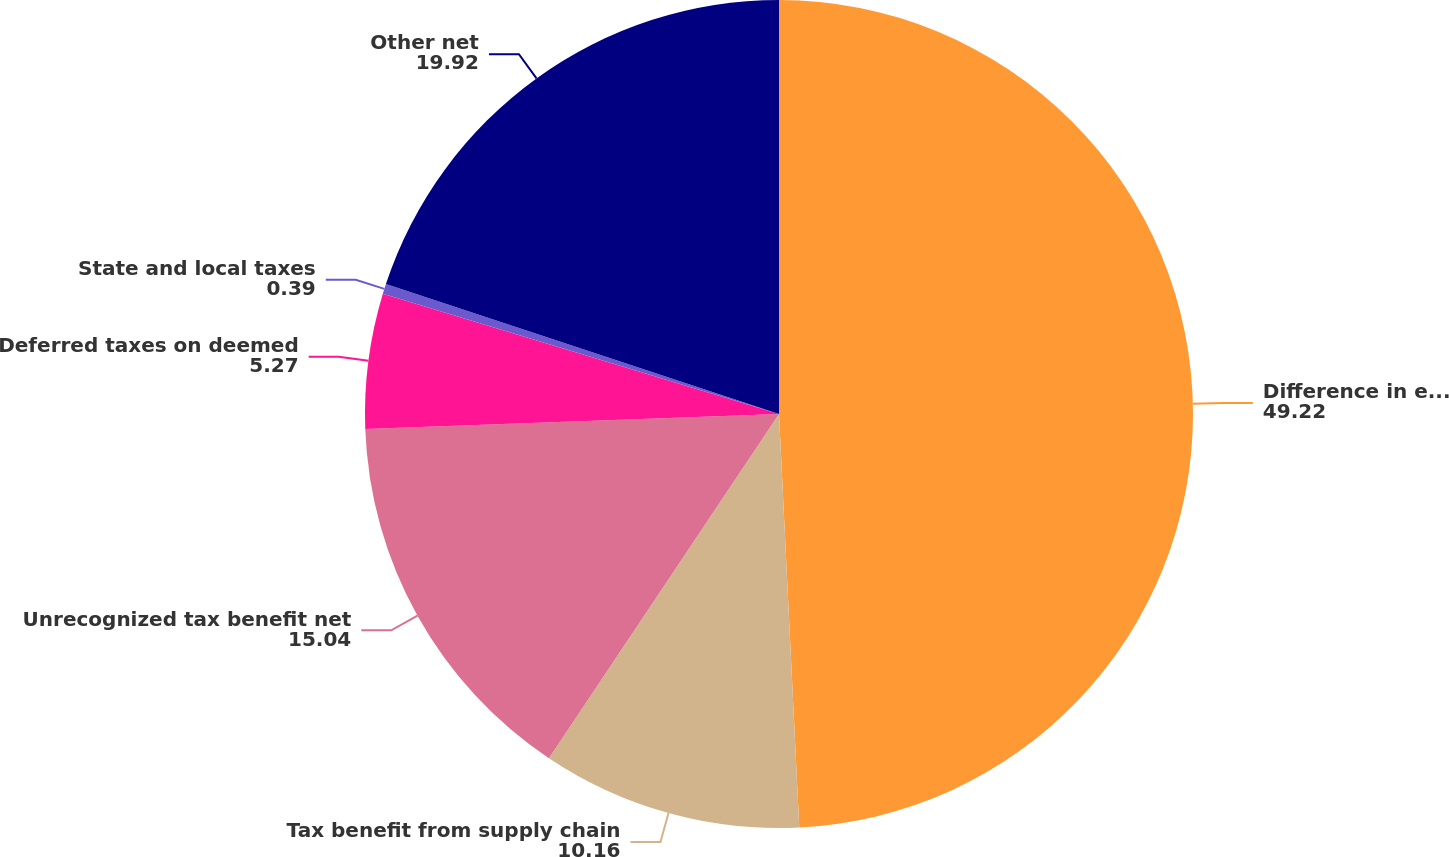Convert chart. <chart><loc_0><loc_0><loc_500><loc_500><pie_chart><fcel>Difference in effective tax<fcel>Tax benefit from supply chain<fcel>Unrecognized tax benefit net<fcel>Deferred taxes on deemed<fcel>State and local taxes<fcel>Other net<nl><fcel>49.22%<fcel>10.16%<fcel>15.04%<fcel>5.27%<fcel>0.39%<fcel>19.92%<nl></chart> 